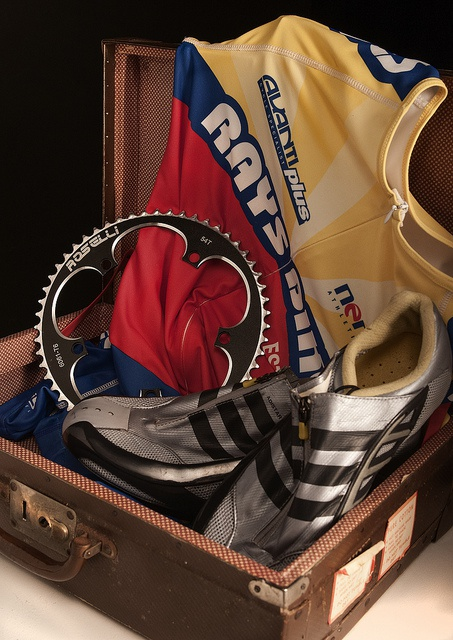Describe the objects in this image and their specific colors. I can see a suitcase in black, maroon, and brown tones in this image. 